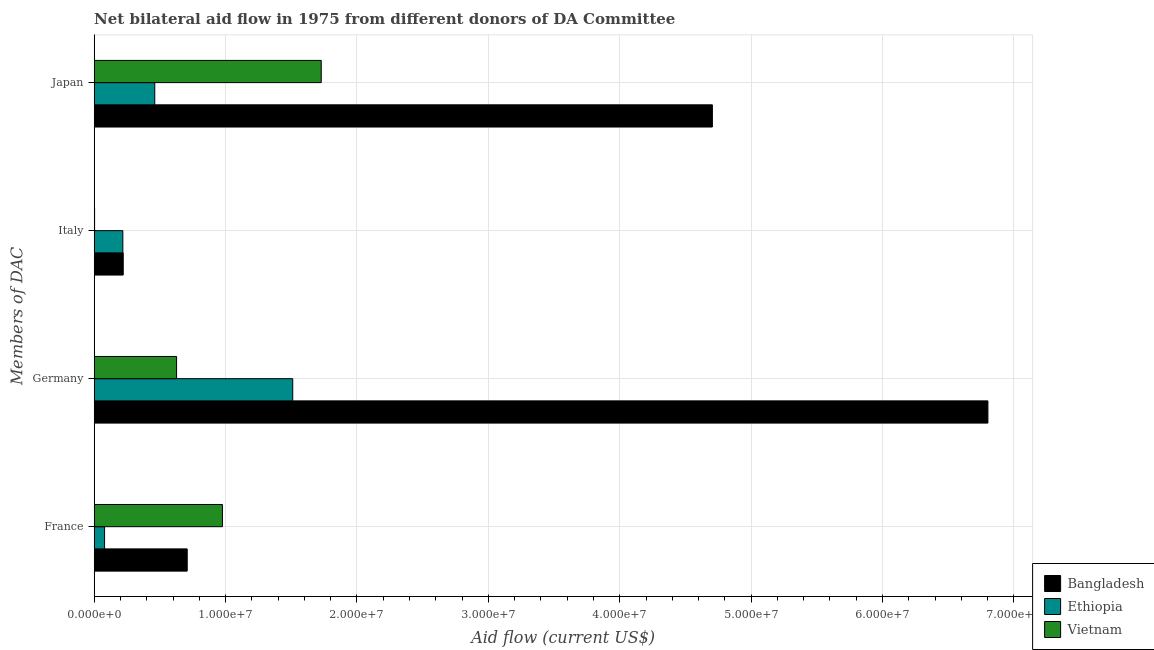How many groups of bars are there?
Offer a very short reply. 4. Are the number of bars per tick equal to the number of legend labels?
Offer a terse response. Yes. Are the number of bars on each tick of the Y-axis equal?
Provide a short and direct response. Yes. How many bars are there on the 1st tick from the top?
Offer a very short reply. 3. How many bars are there on the 1st tick from the bottom?
Ensure brevity in your answer.  3. What is the label of the 2nd group of bars from the top?
Your answer should be compact. Italy. What is the amount of aid given by japan in Ethiopia?
Ensure brevity in your answer.  4.61e+06. Across all countries, what is the maximum amount of aid given by france?
Provide a succinct answer. 9.76e+06. Across all countries, what is the minimum amount of aid given by france?
Provide a short and direct response. 7.90e+05. In which country was the amount of aid given by germany maximum?
Keep it short and to the point. Bangladesh. In which country was the amount of aid given by japan minimum?
Provide a short and direct response. Ethiopia. What is the total amount of aid given by japan in the graph?
Make the answer very short. 6.89e+07. What is the difference between the amount of aid given by japan in Ethiopia and that in Vietnam?
Offer a very short reply. -1.27e+07. What is the difference between the amount of aid given by japan in Bangladesh and the amount of aid given by france in Vietnam?
Provide a succinct answer. 3.73e+07. What is the average amount of aid given by italy per country?
Ensure brevity in your answer.  1.47e+06. What is the difference between the amount of aid given by italy and amount of aid given by germany in Ethiopia?
Give a very brief answer. -1.29e+07. In how many countries, is the amount of aid given by japan greater than 48000000 US$?
Your response must be concise. 0. What is the ratio of the amount of aid given by japan in Vietnam to that in Bangladesh?
Provide a succinct answer. 0.37. Is the amount of aid given by germany in Bangladesh less than that in Vietnam?
Keep it short and to the point. No. What is the difference between the highest and the second highest amount of aid given by france?
Your answer should be very brief. 2.68e+06. What is the difference between the highest and the lowest amount of aid given by germany?
Your answer should be compact. 6.18e+07. In how many countries, is the amount of aid given by france greater than the average amount of aid given by france taken over all countries?
Offer a very short reply. 2. Is the sum of the amount of aid given by italy in Ethiopia and Bangladesh greater than the maximum amount of aid given by germany across all countries?
Offer a terse response. No. Is it the case that in every country, the sum of the amount of aid given by italy and amount of aid given by japan is greater than the sum of amount of aid given by germany and amount of aid given by france?
Provide a succinct answer. Yes. What does the 2nd bar from the top in France represents?
Your response must be concise. Ethiopia. Is it the case that in every country, the sum of the amount of aid given by france and amount of aid given by germany is greater than the amount of aid given by italy?
Keep it short and to the point. Yes. Are all the bars in the graph horizontal?
Provide a short and direct response. Yes. What is the difference between two consecutive major ticks on the X-axis?
Your answer should be very brief. 1.00e+07. Are the values on the major ticks of X-axis written in scientific E-notation?
Offer a terse response. Yes. Does the graph contain any zero values?
Offer a terse response. No. Does the graph contain grids?
Make the answer very short. Yes. Where does the legend appear in the graph?
Provide a succinct answer. Bottom right. What is the title of the graph?
Offer a very short reply. Net bilateral aid flow in 1975 from different donors of DA Committee. Does "Czech Republic" appear as one of the legend labels in the graph?
Ensure brevity in your answer.  No. What is the label or title of the Y-axis?
Offer a terse response. Members of DAC. What is the Aid flow (current US$) in Bangladesh in France?
Provide a short and direct response. 7.08e+06. What is the Aid flow (current US$) in Ethiopia in France?
Offer a terse response. 7.90e+05. What is the Aid flow (current US$) in Vietnam in France?
Your answer should be compact. 9.76e+06. What is the Aid flow (current US$) in Bangladesh in Germany?
Offer a very short reply. 6.80e+07. What is the Aid flow (current US$) of Ethiopia in Germany?
Provide a short and direct response. 1.51e+07. What is the Aid flow (current US$) in Vietnam in Germany?
Offer a terse response. 6.27e+06. What is the Aid flow (current US$) of Bangladesh in Italy?
Offer a very short reply. 2.21e+06. What is the Aid flow (current US$) of Ethiopia in Italy?
Make the answer very short. 2.18e+06. What is the Aid flow (current US$) in Bangladesh in Japan?
Your response must be concise. 4.70e+07. What is the Aid flow (current US$) of Ethiopia in Japan?
Make the answer very short. 4.61e+06. What is the Aid flow (current US$) in Vietnam in Japan?
Make the answer very short. 1.73e+07. Across all Members of DAC, what is the maximum Aid flow (current US$) of Bangladesh?
Make the answer very short. 6.80e+07. Across all Members of DAC, what is the maximum Aid flow (current US$) of Ethiopia?
Make the answer very short. 1.51e+07. Across all Members of DAC, what is the maximum Aid flow (current US$) in Vietnam?
Offer a very short reply. 1.73e+07. Across all Members of DAC, what is the minimum Aid flow (current US$) in Bangladesh?
Offer a terse response. 2.21e+06. Across all Members of DAC, what is the minimum Aid flow (current US$) in Ethiopia?
Offer a very short reply. 7.90e+05. What is the total Aid flow (current US$) of Bangladesh in the graph?
Make the answer very short. 1.24e+08. What is the total Aid flow (current US$) of Ethiopia in the graph?
Give a very brief answer. 2.27e+07. What is the total Aid flow (current US$) of Vietnam in the graph?
Your answer should be compact. 3.33e+07. What is the difference between the Aid flow (current US$) in Bangladesh in France and that in Germany?
Your answer should be compact. -6.09e+07. What is the difference between the Aid flow (current US$) of Ethiopia in France and that in Germany?
Provide a succinct answer. -1.43e+07. What is the difference between the Aid flow (current US$) of Vietnam in France and that in Germany?
Keep it short and to the point. 3.49e+06. What is the difference between the Aid flow (current US$) of Bangladesh in France and that in Italy?
Provide a succinct answer. 4.87e+06. What is the difference between the Aid flow (current US$) in Ethiopia in France and that in Italy?
Keep it short and to the point. -1.39e+06. What is the difference between the Aid flow (current US$) in Vietnam in France and that in Italy?
Ensure brevity in your answer.  9.73e+06. What is the difference between the Aid flow (current US$) in Bangladesh in France and that in Japan?
Give a very brief answer. -4.00e+07. What is the difference between the Aid flow (current US$) in Ethiopia in France and that in Japan?
Provide a short and direct response. -3.82e+06. What is the difference between the Aid flow (current US$) in Vietnam in France and that in Japan?
Give a very brief answer. -7.52e+06. What is the difference between the Aid flow (current US$) in Bangladesh in Germany and that in Italy?
Offer a very short reply. 6.58e+07. What is the difference between the Aid flow (current US$) in Ethiopia in Germany and that in Italy?
Your answer should be very brief. 1.29e+07. What is the difference between the Aid flow (current US$) of Vietnam in Germany and that in Italy?
Ensure brevity in your answer.  6.24e+06. What is the difference between the Aid flow (current US$) in Bangladesh in Germany and that in Japan?
Your answer should be compact. 2.10e+07. What is the difference between the Aid flow (current US$) in Ethiopia in Germany and that in Japan?
Provide a short and direct response. 1.05e+07. What is the difference between the Aid flow (current US$) of Vietnam in Germany and that in Japan?
Your answer should be very brief. -1.10e+07. What is the difference between the Aid flow (current US$) of Bangladesh in Italy and that in Japan?
Make the answer very short. -4.48e+07. What is the difference between the Aid flow (current US$) of Ethiopia in Italy and that in Japan?
Your answer should be very brief. -2.43e+06. What is the difference between the Aid flow (current US$) in Vietnam in Italy and that in Japan?
Your answer should be very brief. -1.72e+07. What is the difference between the Aid flow (current US$) of Bangladesh in France and the Aid flow (current US$) of Ethiopia in Germany?
Keep it short and to the point. -8.03e+06. What is the difference between the Aid flow (current US$) of Bangladesh in France and the Aid flow (current US$) of Vietnam in Germany?
Keep it short and to the point. 8.10e+05. What is the difference between the Aid flow (current US$) of Ethiopia in France and the Aid flow (current US$) of Vietnam in Germany?
Provide a short and direct response. -5.48e+06. What is the difference between the Aid flow (current US$) in Bangladesh in France and the Aid flow (current US$) in Ethiopia in Italy?
Your answer should be compact. 4.90e+06. What is the difference between the Aid flow (current US$) in Bangladesh in France and the Aid flow (current US$) in Vietnam in Italy?
Provide a short and direct response. 7.05e+06. What is the difference between the Aid flow (current US$) of Ethiopia in France and the Aid flow (current US$) of Vietnam in Italy?
Offer a very short reply. 7.60e+05. What is the difference between the Aid flow (current US$) of Bangladesh in France and the Aid flow (current US$) of Ethiopia in Japan?
Your response must be concise. 2.47e+06. What is the difference between the Aid flow (current US$) in Bangladesh in France and the Aid flow (current US$) in Vietnam in Japan?
Provide a short and direct response. -1.02e+07. What is the difference between the Aid flow (current US$) in Ethiopia in France and the Aid flow (current US$) in Vietnam in Japan?
Make the answer very short. -1.65e+07. What is the difference between the Aid flow (current US$) of Bangladesh in Germany and the Aid flow (current US$) of Ethiopia in Italy?
Your answer should be compact. 6.58e+07. What is the difference between the Aid flow (current US$) of Bangladesh in Germany and the Aid flow (current US$) of Vietnam in Italy?
Offer a very short reply. 6.80e+07. What is the difference between the Aid flow (current US$) of Ethiopia in Germany and the Aid flow (current US$) of Vietnam in Italy?
Ensure brevity in your answer.  1.51e+07. What is the difference between the Aid flow (current US$) of Bangladesh in Germany and the Aid flow (current US$) of Ethiopia in Japan?
Ensure brevity in your answer.  6.34e+07. What is the difference between the Aid flow (current US$) of Bangladesh in Germany and the Aid flow (current US$) of Vietnam in Japan?
Provide a short and direct response. 5.07e+07. What is the difference between the Aid flow (current US$) of Ethiopia in Germany and the Aid flow (current US$) of Vietnam in Japan?
Ensure brevity in your answer.  -2.17e+06. What is the difference between the Aid flow (current US$) of Bangladesh in Italy and the Aid flow (current US$) of Ethiopia in Japan?
Offer a very short reply. -2.40e+06. What is the difference between the Aid flow (current US$) of Bangladesh in Italy and the Aid flow (current US$) of Vietnam in Japan?
Provide a succinct answer. -1.51e+07. What is the difference between the Aid flow (current US$) of Ethiopia in Italy and the Aid flow (current US$) of Vietnam in Japan?
Provide a succinct answer. -1.51e+07. What is the average Aid flow (current US$) of Bangladesh per Members of DAC?
Ensure brevity in your answer.  3.11e+07. What is the average Aid flow (current US$) of Ethiopia per Members of DAC?
Provide a short and direct response. 5.67e+06. What is the average Aid flow (current US$) of Vietnam per Members of DAC?
Give a very brief answer. 8.34e+06. What is the difference between the Aid flow (current US$) of Bangladesh and Aid flow (current US$) of Ethiopia in France?
Give a very brief answer. 6.29e+06. What is the difference between the Aid flow (current US$) in Bangladesh and Aid flow (current US$) in Vietnam in France?
Offer a terse response. -2.68e+06. What is the difference between the Aid flow (current US$) of Ethiopia and Aid flow (current US$) of Vietnam in France?
Ensure brevity in your answer.  -8.97e+06. What is the difference between the Aid flow (current US$) of Bangladesh and Aid flow (current US$) of Ethiopia in Germany?
Give a very brief answer. 5.29e+07. What is the difference between the Aid flow (current US$) in Bangladesh and Aid flow (current US$) in Vietnam in Germany?
Offer a terse response. 6.18e+07. What is the difference between the Aid flow (current US$) in Ethiopia and Aid flow (current US$) in Vietnam in Germany?
Provide a succinct answer. 8.84e+06. What is the difference between the Aid flow (current US$) in Bangladesh and Aid flow (current US$) in Ethiopia in Italy?
Your answer should be very brief. 3.00e+04. What is the difference between the Aid flow (current US$) of Bangladesh and Aid flow (current US$) of Vietnam in Italy?
Give a very brief answer. 2.18e+06. What is the difference between the Aid flow (current US$) in Ethiopia and Aid flow (current US$) in Vietnam in Italy?
Ensure brevity in your answer.  2.15e+06. What is the difference between the Aid flow (current US$) in Bangladesh and Aid flow (current US$) in Ethiopia in Japan?
Your answer should be compact. 4.24e+07. What is the difference between the Aid flow (current US$) of Bangladesh and Aid flow (current US$) of Vietnam in Japan?
Provide a succinct answer. 2.98e+07. What is the difference between the Aid flow (current US$) of Ethiopia and Aid flow (current US$) of Vietnam in Japan?
Make the answer very short. -1.27e+07. What is the ratio of the Aid flow (current US$) of Bangladesh in France to that in Germany?
Offer a terse response. 0.1. What is the ratio of the Aid flow (current US$) in Ethiopia in France to that in Germany?
Your response must be concise. 0.05. What is the ratio of the Aid flow (current US$) in Vietnam in France to that in Germany?
Make the answer very short. 1.56. What is the ratio of the Aid flow (current US$) of Bangladesh in France to that in Italy?
Keep it short and to the point. 3.2. What is the ratio of the Aid flow (current US$) in Ethiopia in France to that in Italy?
Give a very brief answer. 0.36. What is the ratio of the Aid flow (current US$) of Vietnam in France to that in Italy?
Ensure brevity in your answer.  325.33. What is the ratio of the Aid flow (current US$) in Bangladesh in France to that in Japan?
Keep it short and to the point. 0.15. What is the ratio of the Aid flow (current US$) of Ethiopia in France to that in Japan?
Provide a succinct answer. 0.17. What is the ratio of the Aid flow (current US$) of Vietnam in France to that in Japan?
Make the answer very short. 0.56. What is the ratio of the Aid flow (current US$) in Bangladesh in Germany to that in Italy?
Provide a short and direct response. 30.78. What is the ratio of the Aid flow (current US$) in Ethiopia in Germany to that in Italy?
Make the answer very short. 6.93. What is the ratio of the Aid flow (current US$) in Vietnam in Germany to that in Italy?
Offer a very short reply. 209. What is the ratio of the Aid flow (current US$) of Bangladesh in Germany to that in Japan?
Offer a terse response. 1.45. What is the ratio of the Aid flow (current US$) in Ethiopia in Germany to that in Japan?
Keep it short and to the point. 3.28. What is the ratio of the Aid flow (current US$) of Vietnam in Germany to that in Japan?
Offer a terse response. 0.36. What is the ratio of the Aid flow (current US$) of Bangladesh in Italy to that in Japan?
Make the answer very short. 0.05. What is the ratio of the Aid flow (current US$) of Ethiopia in Italy to that in Japan?
Provide a short and direct response. 0.47. What is the ratio of the Aid flow (current US$) of Vietnam in Italy to that in Japan?
Give a very brief answer. 0. What is the difference between the highest and the second highest Aid flow (current US$) of Bangladesh?
Offer a very short reply. 2.10e+07. What is the difference between the highest and the second highest Aid flow (current US$) in Ethiopia?
Give a very brief answer. 1.05e+07. What is the difference between the highest and the second highest Aid flow (current US$) of Vietnam?
Make the answer very short. 7.52e+06. What is the difference between the highest and the lowest Aid flow (current US$) of Bangladesh?
Provide a succinct answer. 6.58e+07. What is the difference between the highest and the lowest Aid flow (current US$) of Ethiopia?
Your response must be concise. 1.43e+07. What is the difference between the highest and the lowest Aid flow (current US$) of Vietnam?
Your answer should be very brief. 1.72e+07. 